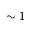Convert formula to latex. <formula><loc_0><loc_0><loc_500><loc_500>\sim 1</formula> 